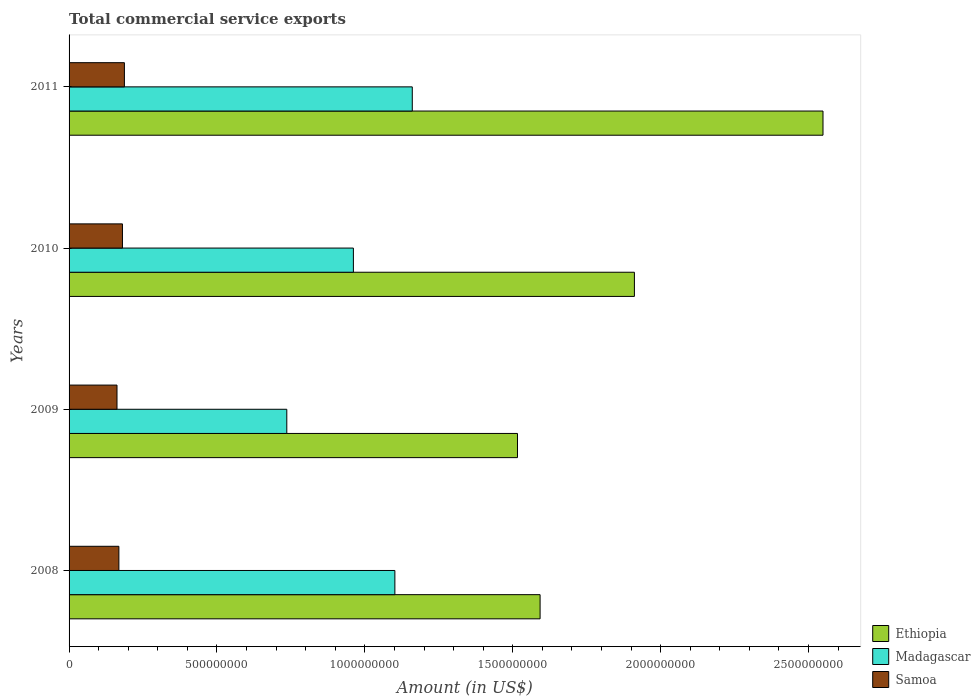How many different coloured bars are there?
Your answer should be compact. 3. How many bars are there on the 4th tick from the top?
Make the answer very short. 3. How many bars are there on the 1st tick from the bottom?
Your answer should be very brief. 3. In how many cases, is the number of bars for a given year not equal to the number of legend labels?
Offer a terse response. 0. What is the total commercial service exports in Samoa in 2011?
Make the answer very short. 1.87e+08. Across all years, what is the maximum total commercial service exports in Madagascar?
Offer a very short reply. 1.16e+09. Across all years, what is the minimum total commercial service exports in Madagascar?
Keep it short and to the point. 7.36e+08. In which year was the total commercial service exports in Samoa maximum?
Keep it short and to the point. 2011. In which year was the total commercial service exports in Samoa minimum?
Your answer should be very brief. 2009. What is the total total commercial service exports in Ethiopia in the graph?
Offer a terse response. 7.57e+09. What is the difference between the total commercial service exports in Ethiopia in 2008 and that in 2010?
Ensure brevity in your answer.  -3.19e+08. What is the difference between the total commercial service exports in Samoa in 2010 and the total commercial service exports in Madagascar in 2011?
Offer a very short reply. -9.80e+08. What is the average total commercial service exports in Ethiopia per year?
Your answer should be compact. 1.89e+09. In the year 2010, what is the difference between the total commercial service exports in Ethiopia and total commercial service exports in Samoa?
Your response must be concise. 1.73e+09. In how many years, is the total commercial service exports in Madagascar greater than 1600000000 US$?
Your answer should be compact. 0. What is the ratio of the total commercial service exports in Ethiopia in 2008 to that in 2011?
Your response must be concise. 0.62. Is the total commercial service exports in Ethiopia in 2009 less than that in 2011?
Keep it short and to the point. Yes. What is the difference between the highest and the second highest total commercial service exports in Samoa?
Your answer should be compact. 6.60e+06. What is the difference between the highest and the lowest total commercial service exports in Madagascar?
Give a very brief answer. 4.24e+08. Is the sum of the total commercial service exports in Madagascar in 2008 and 2009 greater than the maximum total commercial service exports in Ethiopia across all years?
Provide a short and direct response. No. What does the 1st bar from the top in 2010 represents?
Keep it short and to the point. Samoa. What does the 1st bar from the bottom in 2008 represents?
Give a very brief answer. Ethiopia. Is it the case that in every year, the sum of the total commercial service exports in Madagascar and total commercial service exports in Ethiopia is greater than the total commercial service exports in Samoa?
Your response must be concise. Yes. How many bars are there?
Provide a succinct answer. 12. How many years are there in the graph?
Your response must be concise. 4. What is the difference between two consecutive major ticks on the X-axis?
Give a very brief answer. 5.00e+08. Does the graph contain any zero values?
Provide a succinct answer. No. Where does the legend appear in the graph?
Make the answer very short. Bottom right. How are the legend labels stacked?
Your response must be concise. Vertical. What is the title of the graph?
Ensure brevity in your answer.  Total commercial service exports. Does "Dominica" appear as one of the legend labels in the graph?
Provide a short and direct response. No. What is the label or title of the X-axis?
Your answer should be compact. Amount (in US$). What is the label or title of the Y-axis?
Keep it short and to the point. Years. What is the Amount (in US$) in Ethiopia in 2008?
Make the answer very short. 1.59e+09. What is the Amount (in US$) of Madagascar in 2008?
Your answer should be very brief. 1.10e+09. What is the Amount (in US$) in Samoa in 2008?
Provide a short and direct response. 1.68e+08. What is the Amount (in US$) in Ethiopia in 2009?
Your response must be concise. 1.52e+09. What is the Amount (in US$) in Madagascar in 2009?
Provide a succinct answer. 7.36e+08. What is the Amount (in US$) in Samoa in 2009?
Ensure brevity in your answer.  1.62e+08. What is the Amount (in US$) of Ethiopia in 2010?
Your answer should be compact. 1.91e+09. What is the Amount (in US$) in Madagascar in 2010?
Offer a very short reply. 9.61e+08. What is the Amount (in US$) of Samoa in 2010?
Your response must be concise. 1.80e+08. What is the Amount (in US$) of Ethiopia in 2011?
Your answer should be very brief. 2.55e+09. What is the Amount (in US$) in Madagascar in 2011?
Make the answer very short. 1.16e+09. What is the Amount (in US$) of Samoa in 2011?
Provide a short and direct response. 1.87e+08. Across all years, what is the maximum Amount (in US$) in Ethiopia?
Your answer should be very brief. 2.55e+09. Across all years, what is the maximum Amount (in US$) in Madagascar?
Provide a succinct answer. 1.16e+09. Across all years, what is the maximum Amount (in US$) in Samoa?
Give a very brief answer. 1.87e+08. Across all years, what is the minimum Amount (in US$) of Ethiopia?
Give a very brief answer. 1.52e+09. Across all years, what is the minimum Amount (in US$) in Madagascar?
Offer a terse response. 7.36e+08. Across all years, what is the minimum Amount (in US$) in Samoa?
Your answer should be compact. 1.62e+08. What is the total Amount (in US$) of Ethiopia in the graph?
Your answer should be very brief. 7.57e+09. What is the total Amount (in US$) of Madagascar in the graph?
Your answer should be very brief. 3.96e+09. What is the total Amount (in US$) of Samoa in the graph?
Your answer should be compact. 6.98e+08. What is the difference between the Amount (in US$) in Ethiopia in 2008 and that in 2009?
Provide a short and direct response. 7.64e+07. What is the difference between the Amount (in US$) in Madagascar in 2008 and that in 2009?
Offer a very short reply. 3.65e+08. What is the difference between the Amount (in US$) in Samoa in 2008 and that in 2009?
Offer a very short reply. 6.30e+06. What is the difference between the Amount (in US$) of Ethiopia in 2008 and that in 2010?
Your answer should be compact. -3.19e+08. What is the difference between the Amount (in US$) of Madagascar in 2008 and that in 2010?
Your response must be concise. 1.40e+08. What is the difference between the Amount (in US$) of Samoa in 2008 and that in 2010?
Your answer should be very brief. -1.21e+07. What is the difference between the Amount (in US$) of Ethiopia in 2008 and that in 2011?
Your answer should be compact. -9.56e+08. What is the difference between the Amount (in US$) in Madagascar in 2008 and that in 2011?
Provide a short and direct response. -5.88e+07. What is the difference between the Amount (in US$) in Samoa in 2008 and that in 2011?
Ensure brevity in your answer.  -1.87e+07. What is the difference between the Amount (in US$) of Ethiopia in 2009 and that in 2010?
Your response must be concise. -3.95e+08. What is the difference between the Amount (in US$) of Madagascar in 2009 and that in 2010?
Ensure brevity in your answer.  -2.25e+08. What is the difference between the Amount (in US$) in Samoa in 2009 and that in 2010?
Keep it short and to the point. -1.84e+07. What is the difference between the Amount (in US$) of Ethiopia in 2009 and that in 2011?
Provide a succinct answer. -1.03e+09. What is the difference between the Amount (in US$) in Madagascar in 2009 and that in 2011?
Make the answer very short. -4.24e+08. What is the difference between the Amount (in US$) in Samoa in 2009 and that in 2011?
Give a very brief answer. -2.50e+07. What is the difference between the Amount (in US$) in Ethiopia in 2010 and that in 2011?
Your response must be concise. -6.38e+08. What is the difference between the Amount (in US$) of Madagascar in 2010 and that in 2011?
Make the answer very short. -1.99e+08. What is the difference between the Amount (in US$) of Samoa in 2010 and that in 2011?
Your answer should be very brief. -6.60e+06. What is the difference between the Amount (in US$) in Ethiopia in 2008 and the Amount (in US$) in Madagascar in 2009?
Your answer should be compact. 8.56e+08. What is the difference between the Amount (in US$) of Ethiopia in 2008 and the Amount (in US$) of Samoa in 2009?
Keep it short and to the point. 1.43e+09. What is the difference between the Amount (in US$) in Madagascar in 2008 and the Amount (in US$) in Samoa in 2009?
Your answer should be compact. 9.39e+08. What is the difference between the Amount (in US$) in Ethiopia in 2008 and the Amount (in US$) in Madagascar in 2010?
Offer a very short reply. 6.31e+08. What is the difference between the Amount (in US$) in Ethiopia in 2008 and the Amount (in US$) in Samoa in 2010?
Provide a short and direct response. 1.41e+09. What is the difference between the Amount (in US$) in Madagascar in 2008 and the Amount (in US$) in Samoa in 2010?
Give a very brief answer. 9.21e+08. What is the difference between the Amount (in US$) in Ethiopia in 2008 and the Amount (in US$) in Madagascar in 2011?
Your answer should be very brief. 4.32e+08. What is the difference between the Amount (in US$) of Ethiopia in 2008 and the Amount (in US$) of Samoa in 2011?
Your answer should be compact. 1.41e+09. What is the difference between the Amount (in US$) of Madagascar in 2008 and the Amount (in US$) of Samoa in 2011?
Provide a short and direct response. 9.14e+08. What is the difference between the Amount (in US$) in Ethiopia in 2009 and the Amount (in US$) in Madagascar in 2010?
Your response must be concise. 5.55e+08. What is the difference between the Amount (in US$) in Ethiopia in 2009 and the Amount (in US$) in Samoa in 2010?
Your response must be concise. 1.34e+09. What is the difference between the Amount (in US$) in Madagascar in 2009 and the Amount (in US$) in Samoa in 2010?
Make the answer very short. 5.56e+08. What is the difference between the Amount (in US$) in Ethiopia in 2009 and the Amount (in US$) in Madagascar in 2011?
Your response must be concise. 3.56e+08. What is the difference between the Amount (in US$) of Ethiopia in 2009 and the Amount (in US$) of Samoa in 2011?
Offer a very short reply. 1.33e+09. What is the difference between the Amount (in US$) of Madagascar in 2009 and the Amount (in US$) of Samoa in 2011?
Your answer should be very brief. 5.49e+08. What is the difference between the Amount (in US$) of Ethiopia in 2010 and the Amount (in US$) of Madagascar in 2011?
Offer a very short reply. 7.51e+08. What is the difference between the Amount (in US$) of Ethiopia in 2010 and the Amount (in US$) of Samoa in 2011?
Provide a succinct answer. 1.72e+09. What is the difference between the Amount (in US$) of Madagascar in 2010 and the Amount (in US$) of Samoa in 2011?
Your response must be concise. 7.74e+08. What is the average Amount (in US$) in Ethiopia per year?
Your answer should be compact. 1.89e+09. What is the average Amount (in US$) in Madagascar per year?
Provide a short and direct response. 9.90e+08. What is the average Amount (in US$) in Samoa per year?
Offer a very short reply. 1.74e+08. In the year 2008, what is the difference between the Amount (in US$) in Ethiopia and Amount (in US$) in Madagascar?
Make the answer very short. 4.91e+08. In the year 2008, what is the difference between the Amount (in US$) in Ethiopia and Amount (in US$) in Samoa?
Your response must be concise. 1.42e+09. In the year 2008, what is the difference between the Amount (in US$) of Madagascar and Amount (in US$) of Samoa?
Provide a succinct answer. 9.33e+08. In the year 2009, what is the difference between the Amount (in US$) in Ethiopia and Amount (in US$) in Madagascar?
Offer a very short reply. 7.80e+08. In the year 2009, what is the difference between the Amount (in US$) of Ethiopia and Amount (in US$) of Samoa?
Keep it short and to the point. 1.35e+09. In the year 2009, what is the difference between the Amount (in US$) of Madagascar and Amount (in US$) of Samoa?
Keep it short and to the point. 5.74e+08. In the year 2010, what is the difference between the Amount (in US$) of Ethiopia and Amount (in US$) of Madagascar?
Offer a very short reply. 9.50e+08. In the year 2010, what is the difference between the Amount (in US$) in Ethiopia and Amount (in US$) in Samoa?
Offer a very short reply. 1.73e+09. In the year 2010, what is the difference between the Amount (in US$) of Madagascar and Amount (in US$) of Samoa?
Keep it short and to the point. 7.81e+08. In the year 2011, what is the difference between the Amount (in US$) of Ethiopia and Amount (in US$) of Madagascar?
Provide a succinct answer. 1.39e+09. In the year 2011, what is the difference between the Amount (in US$) in Ethiopia and Amount (in US$) in Samoa?
Provide a short and direct response. 2.36e+09. In the year 2011, what is the difference between the Amount (in US$) in Madagascar and Amount (in US$) in Samoa?
Offer a terse response. 9.73e+08. What is the ratio of the Amount (in US$) of Ethiopia in 2008 to that in 2009?
Your answer should be compact. 1.05. What is the ratio of the Amount (in US$) of Madagascar in 2008 to that in 2009?
Your answer should be very brief. 1.5. What is the ratio of the Amount (in US$) in Samoa in 2008 to that in 2009?
Make the answer very short. 1.04. What is the ratio of the Amount (in US$) in Ethiopia in 2008 to that in 2010?
Your response must be concise. 0.83. What is the ratio of the Amount (in US$) of Madagascar in 2008 to that in 2010?
Your answer should be very brief. 1.15. What is the ratio of the Amount (in US$) of Samoa in 2008 to that in 2010?
Your response must be concise. 0.93. What is the ratio of the Amount (in US$) in Ethiopia in 2008 to that in 2011?
Ensure brevity in your answer.  0.62. What is the ratio of the Amount (in US$) in Madagascar in 2008 to that in 2011?
Ensure brevity in your answer.  0.95. What is the ratio of the Amount (in US$) in Samoa in 2008 to that in 2011?
Your answer should be very brief. 0.9. What is the ratio of the Amount (in US$) in Ethiopia in 2009 to that in 2010?
Offer a terse response. 0.79. What is the ratio of the Amount (in US$) in Madagascar in 2009 to that in 2010?
Provide a short and direct response. 0.77. What is the ratio of the Amount (in US$) in Samoa in 2009 to that in 2010?
Your answer should be compact. 0.9. What is the ratio of the Amount (in US$) in Ethiopia in 2009 to that in 2011?
Your response must be concise. 0.59. What is the ratio of the Amount (in US$) of Madagascar in 2009 to that in 2011?
Your answer should be compact. 0.63. What is the ratio of the Amount (in US$) in Samoa in 2009 to that in 2011?
Provide a short and direct response. 0.87. What is the ratio of the Amount (in US$) in Ethiopia in 2010 to that in 2011?
Offer a terse response. 0.75. What is the ratio of the Amount (in US$) in Madagascar in 2010 to that in 2011?
Keep it short and to the point. 0.83. What is the ratio of the Amount (in US$) of Samoa in 2010 to that in 2011?
Ensure brevity in your answer.  0.96. What is the difference between the highest and the second highest Amount (in US$) in Ethiopia?
Offer a terse response. 6.38e+08. What is the difference between the highest and the second highest Amount (in US$) in Madagascar?
Keep it short and to the point. 5.88e+07. What is the difference between the highest and the second highest Amount (in US$) of Samoa?
Offer a terse response. 6.60e+06. What is the difference between the highest and the lowest Amount (in US$) of Ethiopia?
Your answer should be very brief. 1.03e+09. What is the difference between the highest and the lowest Amount (in US$) of Madagascar?
Your response must be concise. 4.24e+08. What is the difference between the highest and the lowest Amount (in US$) of Samoa?
Provide a succinct answer. 2.50e+07. 